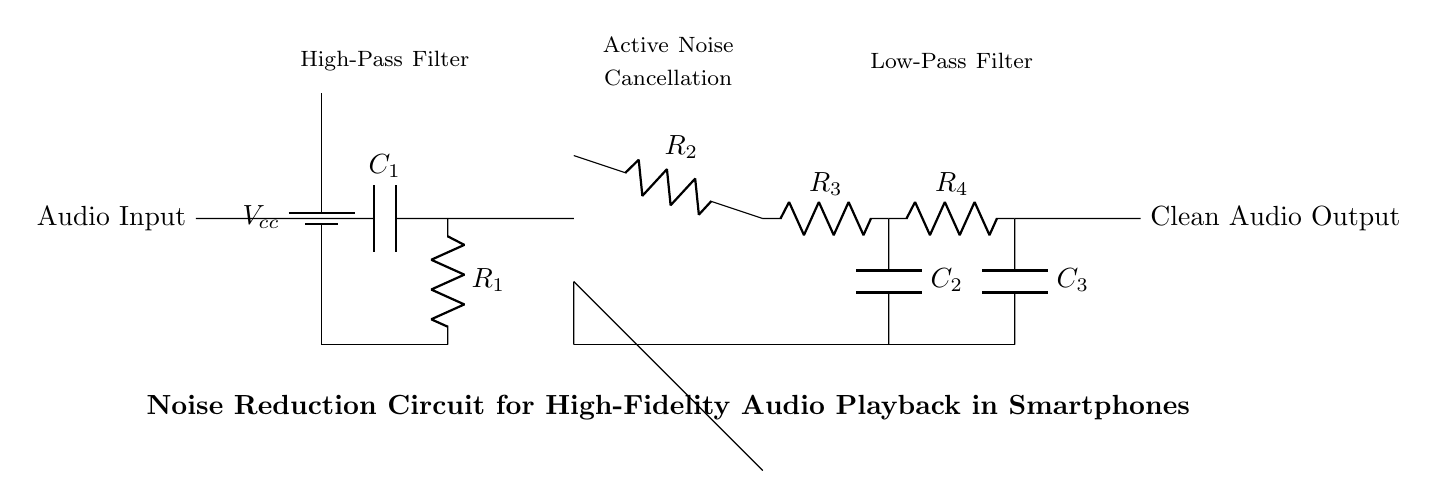What is the power supply voltage of this circuit? The power supply is labeled as Vcc, which indicates the voltage level provided to the circuit. This is common in electronics and can be found at the top of the circuit where the battery is depicted.
Answer: Vcc What type of filter is the first stage? The first stage consists of a capacitor and a resistor, which together form a high-pass filter. This can be deduced from the arrangement of a capacitor in series with the resistor, allowing high-frequency signals to pass while blocking lower frequencies.
Answer: High-pass filter What is the function of the op-amp in this circuit? The op-amp is shown in the circuit without any additional connections at its inverting terminal, indicated by the configuration, which suggests that it is amplifying the incoming audio signal while also providing noise cancellation. This is a key part of the active noise cancellation process.
Answer: Amplification What components comprise the feedback network of the op-amp? The feedback network includes a resistor labeled R3 and a capacitor labeled C2 connected to the output of the op-amp, looping back to the inverting terminal. This arrangement is crucial for setting the gain and frequency response of the op-amp.
Answer: R3 and C2 What type of filter is the last stage? The last stage consists of a resistor and a capacitor in series, configured to form a low-pass filter that allows only low-frequency signals to pass through, effectively reducing any high-frequency noise that may remain after the preceding stages.
Answer: Low-pass filter 